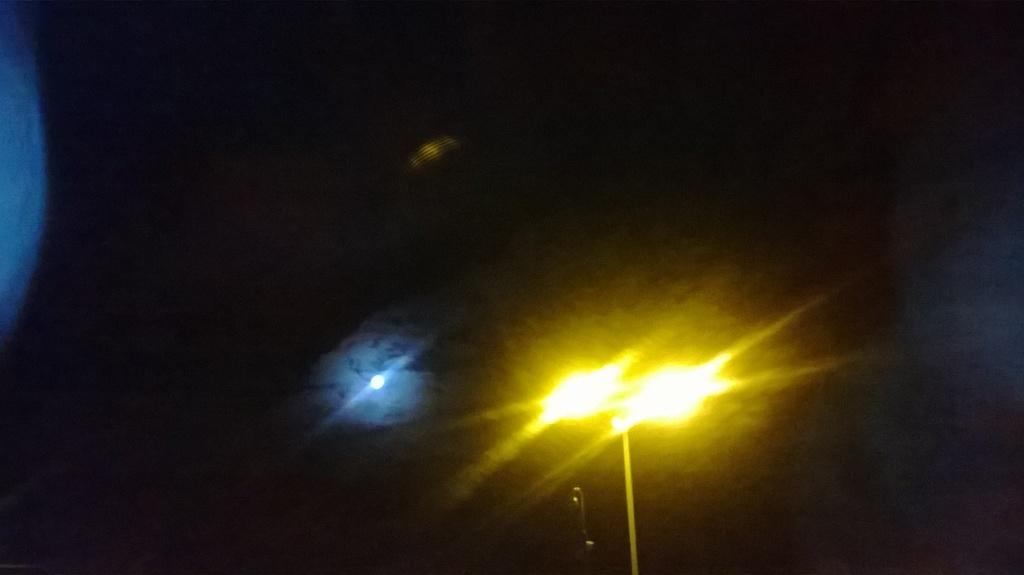What is located in the center of the image? There are lights in the center of the image. Can you describe the overall lighting condition in the image? The image is in the dark. What year did the parent carpenter build the lights in the image? There is no reference to a parent or carpenter in the image, and therefore no such information can be determined. 